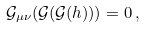<formula> <loc_0><loc_0><loc_500><loc_500>\mathcal { G } _ { \mu \nu } ( \mathcal { G } ( \mathcal { G } ( h ) ) ) = 0 \, ,</formula> 